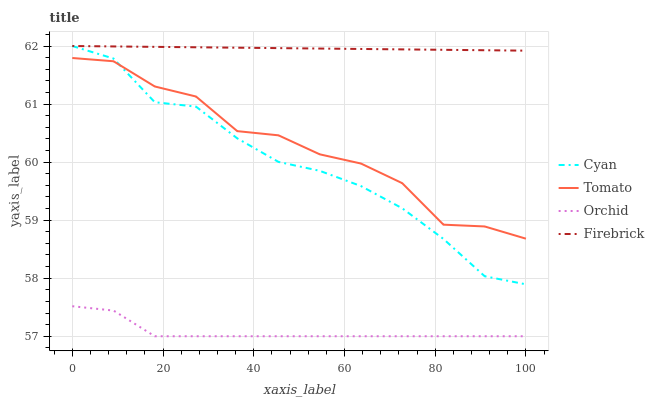Does Cyan have the minimum area under the curve?
Answer yes or no. No. Does Cyan have the maximum area under the curve?
Answer yes or no. No. Is Cyan the smoothest?
Answer yes or no. No. Is Cyan the roughest?
Answer yes or no. No. Does Cyan have the lowest value?
Answer yes or no. No. Does Orchid have the highest value?
Answer yes or no. No. Is Tomato less than Firebrick?
Answer yes or no. Yes. Is Tomato greater than Orchid?
Answer yes or no. Yes. Does Tomato intersect Firebrick?
Answer yes or no. No. 